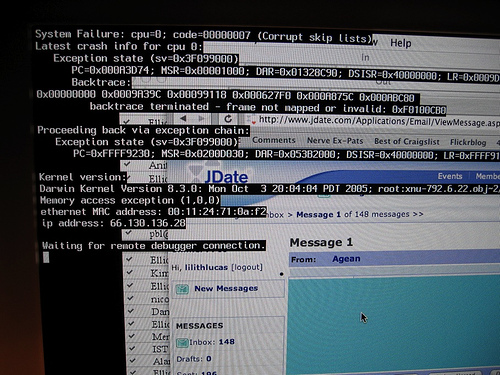Read all the text in this image. 1 Message JDate Help backtrace version exception Flickrblog LR=8xFFFF9 Events memb 2 obj 22 6 792 xnu root 2885 PTD 84 81 28 Agean messages 148 of 1 Message hbox From MESSAGES Inbox 148 O Drafts Alan IST Ellie Dan nico Ellit Kim Ellic New Messages [logout] IIIITHLUCAS HI Connection debugger renote for waiting pol 136 130 66 lp address ethernet MAC address exception access Memory 28 1,0.0 71 24 11 00 3 Oct Mon 8 . 3. 0 Version Kernel Darwin Kernel Ellie Anil via back Proceeding Exception state PC=0xFFFF9230 MSR=0X0200D030 ksv=BF099000 chain terminated DAR=0x05382000 DSISR=0X400000000 Craigslist Of EX-Pats Nerve Comments http//www.jdate.com APPLICATIONS Email VlewMessage.as oxfoippcB8 0X888ABC80 LR=0X08890 DSISR=0X4888888; invalld or napped NOT frane 0X000RB75C 8x000627F0 DAR=0X01328C90 lists skip (Corrupt code ooooooo7 0x00099118 0X0009A39C 0x00000000 Backtrace PC=0x000A3D74 state Exception 8 cpu for info crash Latest CPU=O Failure System 